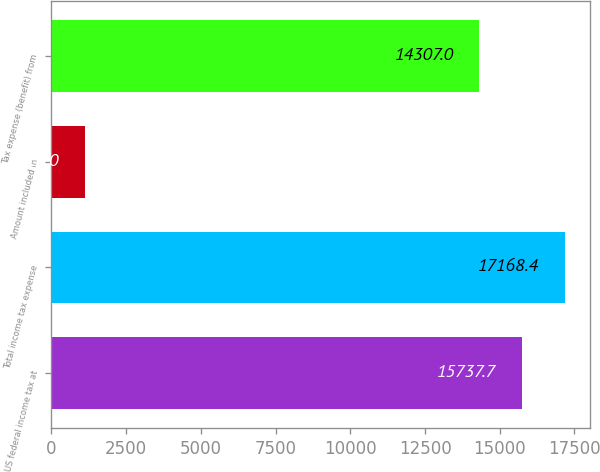Convert chart to OTSL. <chart><loc_0><loc_0><loc_500><loc_500><bar_chart><fcel>US federal income tax at<fcel>Total income tax expense<fcel>Amount included in<fcel>Tax expense (benefit) from<nl><fcel>15737.7<fcel>17168.4<fcel>1116<fcel>14307<nl></chart> 